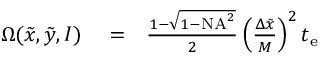Convert formula to latex. <formula><loc_0><loc_0><loc_500><loc_500>\begin{array} { r l r } { \Omega ( \tilde { x } , \tilde { y } , I ) } & = } & { \frac { 1 - \sqrt { 1 - N A ^ { 2 } } } { 2 } \left ( \frac { \Delta \tilde { x } } { M } \right ) ^ { 2 } t _ { e } } \end{array}</formula> 